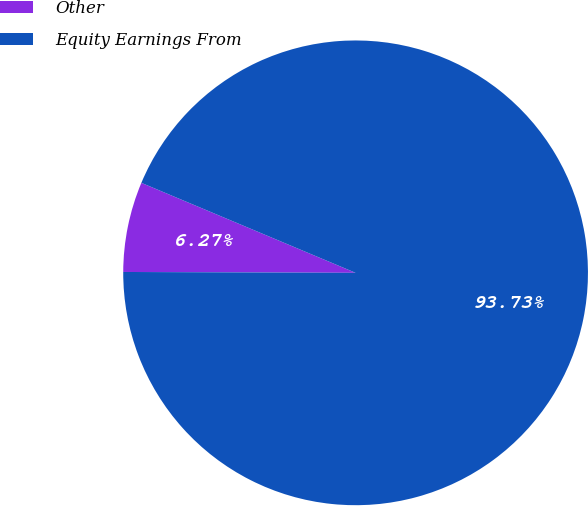<chart> <loc_0><loc_0><loc_500><loc_500><pie_chart><fcel>Other<fcel>Equity Earnings From<nl><fcel>6.27%<fcel>93.73%<nl></chart> 